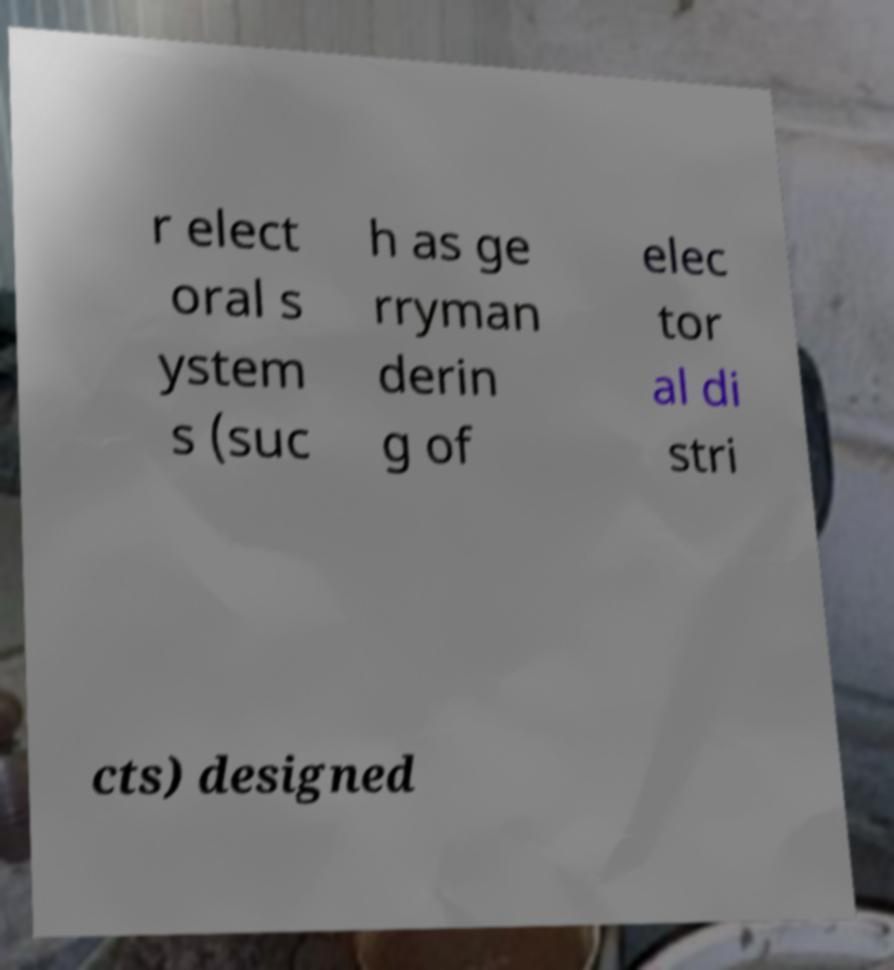Please read and relay the text visible in this image. What does it say? r elect oral s ystem s (suc h as ge rryman derin g of elec tor al di stri cts) designed 